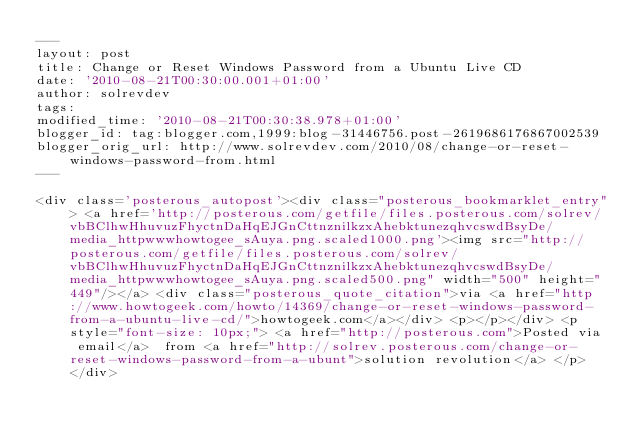Convert code to text. <code><loc_0><loc_0><loc_500><loc_500><_HTML_>---
layout: post
title: Change or Reset Windows Password from a Ubuntu Live CD
date: '2010-08-21T00:30:00.001+01:00'
author: solrevdev
tags: 
modified_time: '2010-08-21T00:30:38.978+01:00'
blogger_id: tag:blogger.com,1999:blog-31446756.post-2619686176867002539
blogger_orig_url: http://www.solrevdev.com/2010/08/change-or-reset-windows-password-from.html
---

<div class='posterous_autopost'><div class="posterous_bookmarklet_entry"> <a href='http://posterous.com/getfile/files.posterous.com/solrev/vbBClhwHhuvuzFhyctnDaHqEJGnCttnznilkzxAhebktunezqhvcswdBsyDe/media_httpwwwhowtogee_sAuya.png.scaled1000.png'><img src="http://posterous.com/getfile/files.posterous.com/solrev/vbBClhwHhuvuzFhyctnDaHqEJGnCttnznilkzxAhebktunezqhvcswdBsyDe/media_httpwwwhowtogee_sAuya.png.scaled500.png" width="500" height="449"/></a> <div class="posterous_quote_citation">via <a href="http://www.howtogeek.com/howto/14369/change-or-reset-windows-password-from-a-ubuntu-live-cd/">howtogeek.com</a></div> <p></p></div> <p style="font-size: 10px;"> <a href="http://posterous.com">Posted via email</a>  from <a href="http://solrev.posterous.com/change-or-reset-windows-password-from-a-ubunt">solution revolution</a> </p> </div></code> 